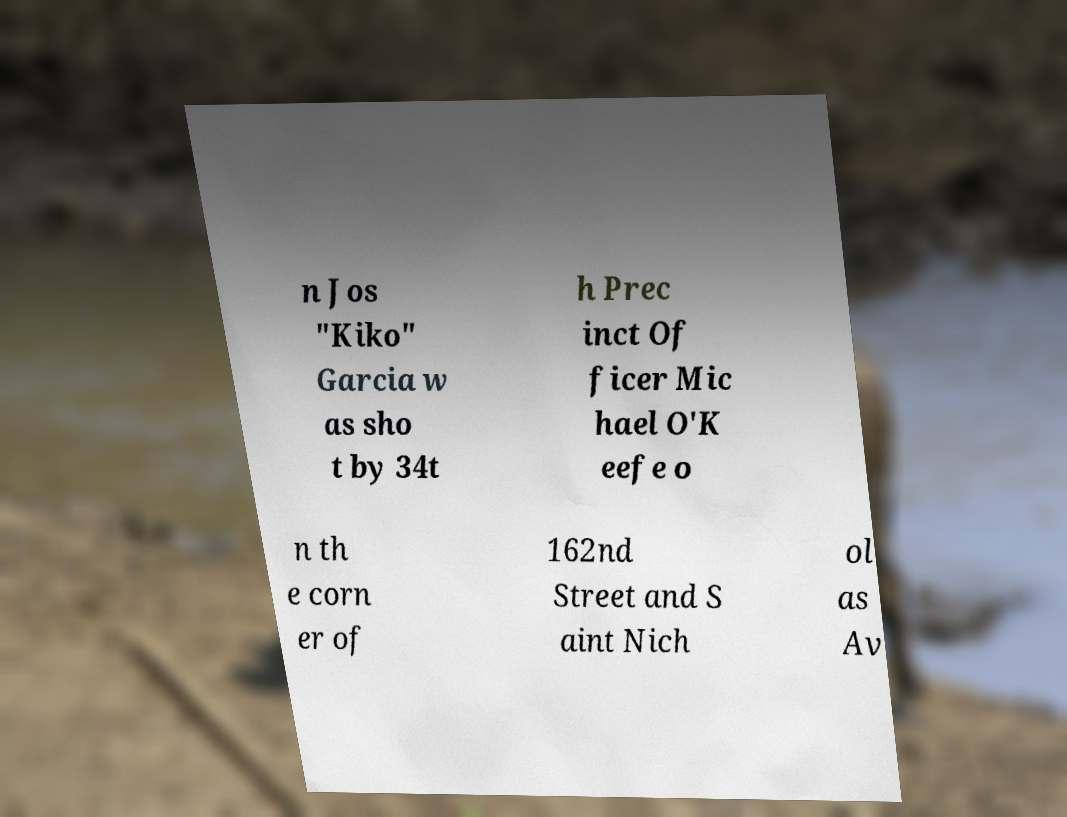There's text embedded in this image that I need extracted. Can you transcribe it verbatim? n Jos "Kiko" Garcia w as sho t by 34t h Prec inct Of ficer Mic hael O'K eefe o n th e corn er of 162nd Street and S aint Nich ol as Av 